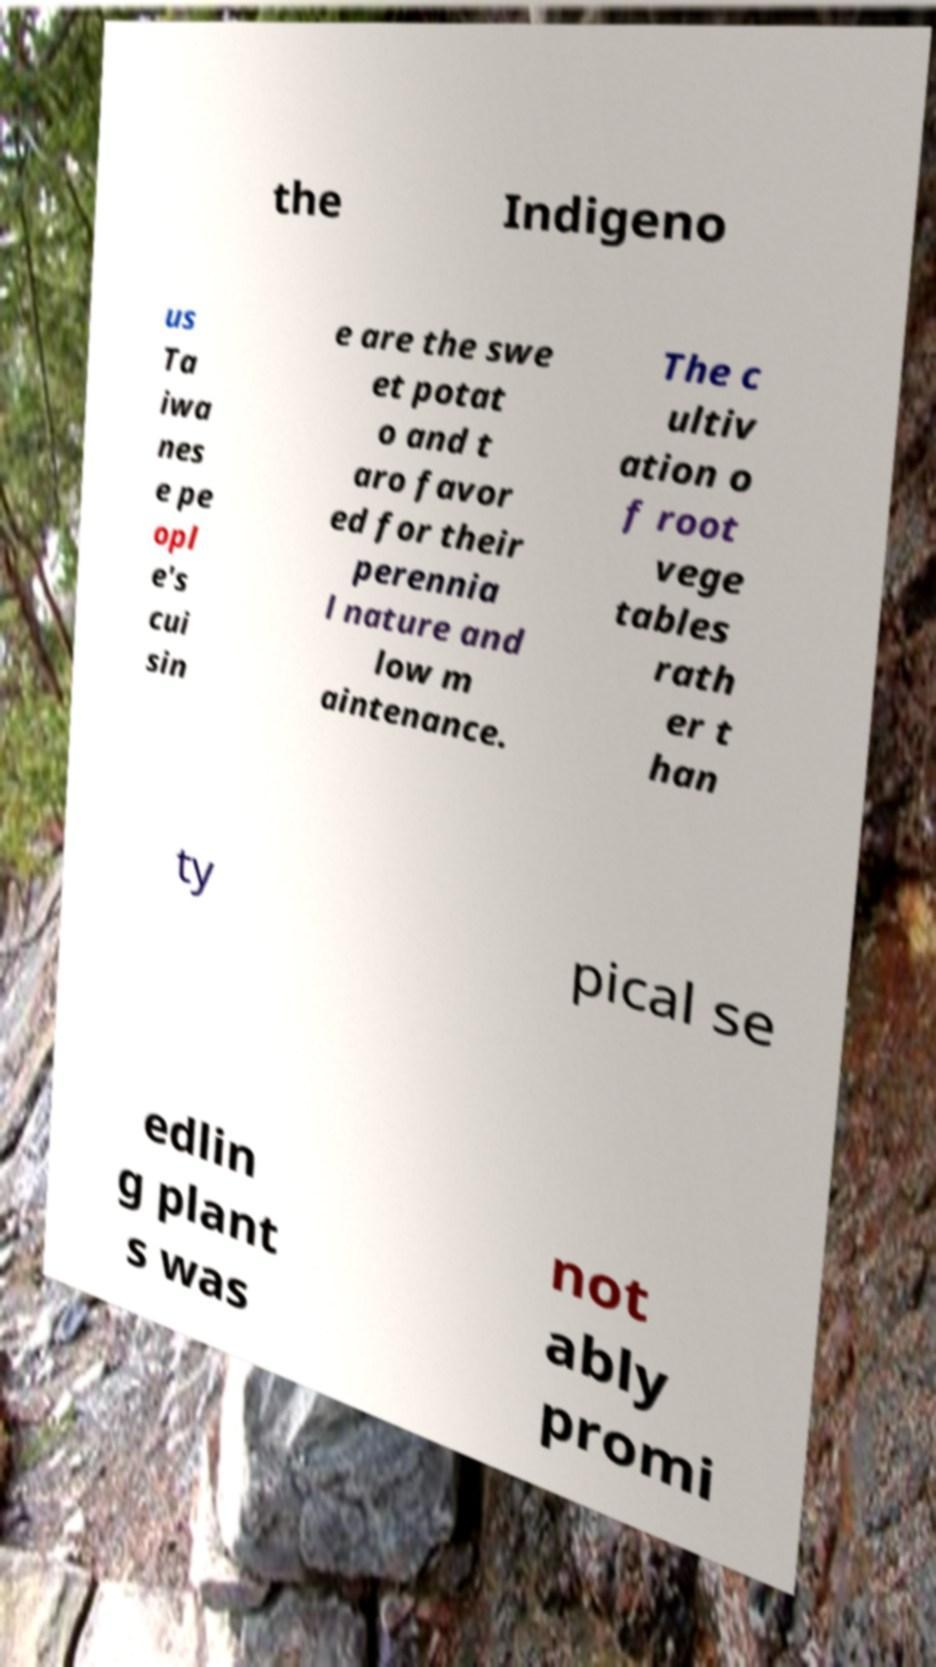There's text embedded in this image that I need extracted. Can you transcribe it verbatim? the Indigeno us Ta iwa nes e pe opl e's cui sin e are the swe et potat o and t aro favor ed for their perennia l nature and low m aintenance. The c ultiv ation o f root vege tables rath er t han ty pical se edlin g plant s was not ably promi 